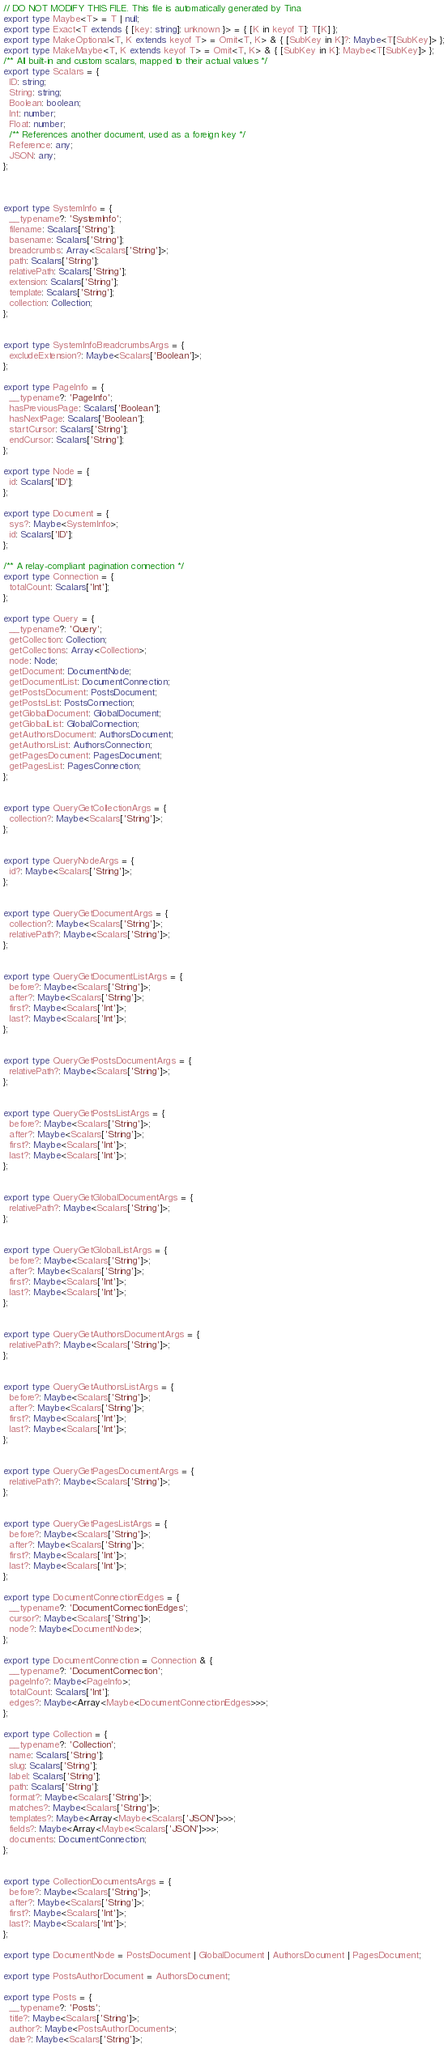<code> <loc_0><loc_0><loc_500><loc_500><_TypeScript_>// DO NOT MODIFY THIS FILE. This file is automatically generated by Tina
export type Maybe<T> = T | null;
export type Exact<T extends { [key: string]: unknown }> = { [K in keyof T]: T[K] };
export type MakeOptional<T, K extends keyof T> = Omit<T, K> & { [SubKey in K]?: Maybe<T[SubKey]> };
export type MakeMaybe<T, K extends keyof T> = Omit<T, K> & { [SubKey in K]: Maybe<T[SubKey]> };
/** All built-in and custom scalars, mapped to their actual values */
export type Scalars = {
  ID: string;
  String: string;
  Boolean: boolean;
  Int: number;
  Float: number;
  /** References another document, used as a foreign key */
  Reference: any;
  JSON: any;
};



export type SystemInfo = {
  __typename?: 'SystemInfo';
  filename: Scalars['String'];
  basename: Scalars['String'];
  breadcrumbs: Array<Scalars['String']>;
  path: Scalars['String'];
  relativePath: Scalars['String'];
  extension: Scalars['String'];
  template: Scalars['String'];
  collection: Collection;
};


export type SystemInfoBreadcrumbsArgs = {
  excludeExtension?: Maybe<Scalars['Boolean']>;
};

export type PageInfo = {
  __typename?: 'PageInfo';
  hasPreviousPage: Scalars['Boolean'];
  hasNextPage: Scalars['Boolean'];
  startCursor: Scalars['String'];
  endCursor: Scalars['String'];
};

export type Node = {
  id: Scalars['ID'];
};

export type Document = {
  sys?: Maybe<SystemInfo>;
  id: Scalars['ID'];
};

/** A relay-compliant pagination connection */
export type Connection = {
  totalCount: Scalars['Int'];
};

export type Query = {
  __typename?: 'Query';
  getCollection: Collection;
  getCollections: Array<Collection>;
  node: Node;
  getDocument: DocumentNode;
  getDocumentList: DocumentConnection;
  getPostsDocument: PostsDocument;
  getPostsList: PostsConnection;
  getGlobalDocument: GlobalDocument;
  getGlobalList: GlobalConnection;
  getAuthorsDocument: AuthorsDocument;
  getAuthorsList: AuthorsConnection;
  getPagesDocument: PagesDocument;
  getPagesList: PagesConnection;
};


export type QueryGetCollectionArgs = {
  collection?: Maybe<Scalars['String']>;
};


export type QueryNodeArgs = {
  id?: Maybe<Scalars['String']>;
};


export type QueryGetDocumentArgs = {
  collection?: Maybe<Scalars['String']>;
  relativePath?: Maybe<Scalars['String']>;
};


export type QueryGetDocumentListArgs = {
  before?: Maybe<Scalars['String']>;
  after?: Maybe<Scalars['String']>;
  first?: Maybe<Scalars['Int']>;
  last?: Maybe<Scalars['Int']>;
};


export type QueryGetPostsDocumentArgs = {
  relativePath?: Maybe<Scalars['String']>;
};


export type QueryGetPostsListArgs = {
  before?: Maybe<Scalars['String']>;
  after?: Maybe<Scalars['String']>;
  first?: Maybe<Scalars['Int']>;
  last?: Maybe<Scalars['Int']>;
};


export type QueryGetGlobalDocumentArgs = {
  relativePath?: Maybe<Scalars['String']>;
};


export type QueryGetGlobalListArgs = {
  before?: Maybe<Scalars['String']>;
  after?: Maybe<Scalars['String']>;
  first?: Maybe<Scalars['Int']>;
  last?: Maybe<Scalars['Int']>;
};


export type QueryGetAuthorsDocumentArgs = {
  relativePath?: Maybe<Scalars['String']>;
};


export type QueryGetAuthorsListArgs = {
  before?: Maybe<Scalars['String']>;
  after?: Maybe<Scalars['String']>;
  first?: Maybe<Scalars['Int']>;
  last?: Maybe<Scalars['Int']>;
};


export type QueryGetPagesDocumentArgs = {
  relativePath?: Maybe<Scalars['String']>;
};


export type QueryGetPagesListArgs = {
  before?: Maybe<Scalars['String']>;
  after?: Maybe<Scalars['String']>;
  first?: Maybe<Scalars['Int']>;
  last?: Maybe<Scalars['Int']>;
};

export type DocumentConnectionEdges = {
  __typename?: 'DocumentConnectionEdges';
  cursor?: Maybe<Scalars['String']>;
  node?: Maybe<DocumentNode>;
};

export type DocumentConnection = Connection & {
  __typename?: 'DocumentConnection';
  pageInfo?: Maybe<PageInfo>;
  totalCount: Scalars['Int'];
  edges?: Maybe<Array<Maybe<DocumentConnectionEdges>>>;
};

export type Collection = {
  __typename?: 'Collection';
  name: Scalars['String'];
  slug: Scalars['String'];
  label: Scalars['String'];
  path: Scalars['String'];
  format?: Maybe<Scalars['String']>;
  matches?: Maybe<Scalars['String']>;
  templates?: Maybe<Array<Maybe<Scalars['JSON']>>>;
  fields?: Maybe<Array<Maybe<Scalars['JSON']>>>;
  documents: DocumentConnection;
};


export type CollectionDocumentsArgs = {
  before?: Maybe<Scalars['String']>;
  after?: Maybe<Scalars['String']>;
  first?: Maybe<Scalars['Int']>;
  last?: Maybe<Scalars['Int']>;
};

export type DocumentNode = PostsDocument | GlobalDocument | AuthorsDocument | PagesDocument;

export type PostsAuthorDocument = AuthorsDocument;

export type Posts = {
  __typename?: 'Posts';
  title?: Maybe<Scalars['String']>;
  author?: Maybe<PostsAuthorDocument>;
  date?: Maybe<Scalars['String']>;</code> 